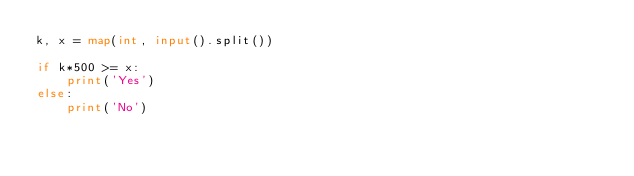<code> <loc_0><loc_0><loc_500><loc_500><_Python_>k, x = map(int, input().split())

if k*500 >= x:
    print('Yes')
else:
    print('No')
</code> 